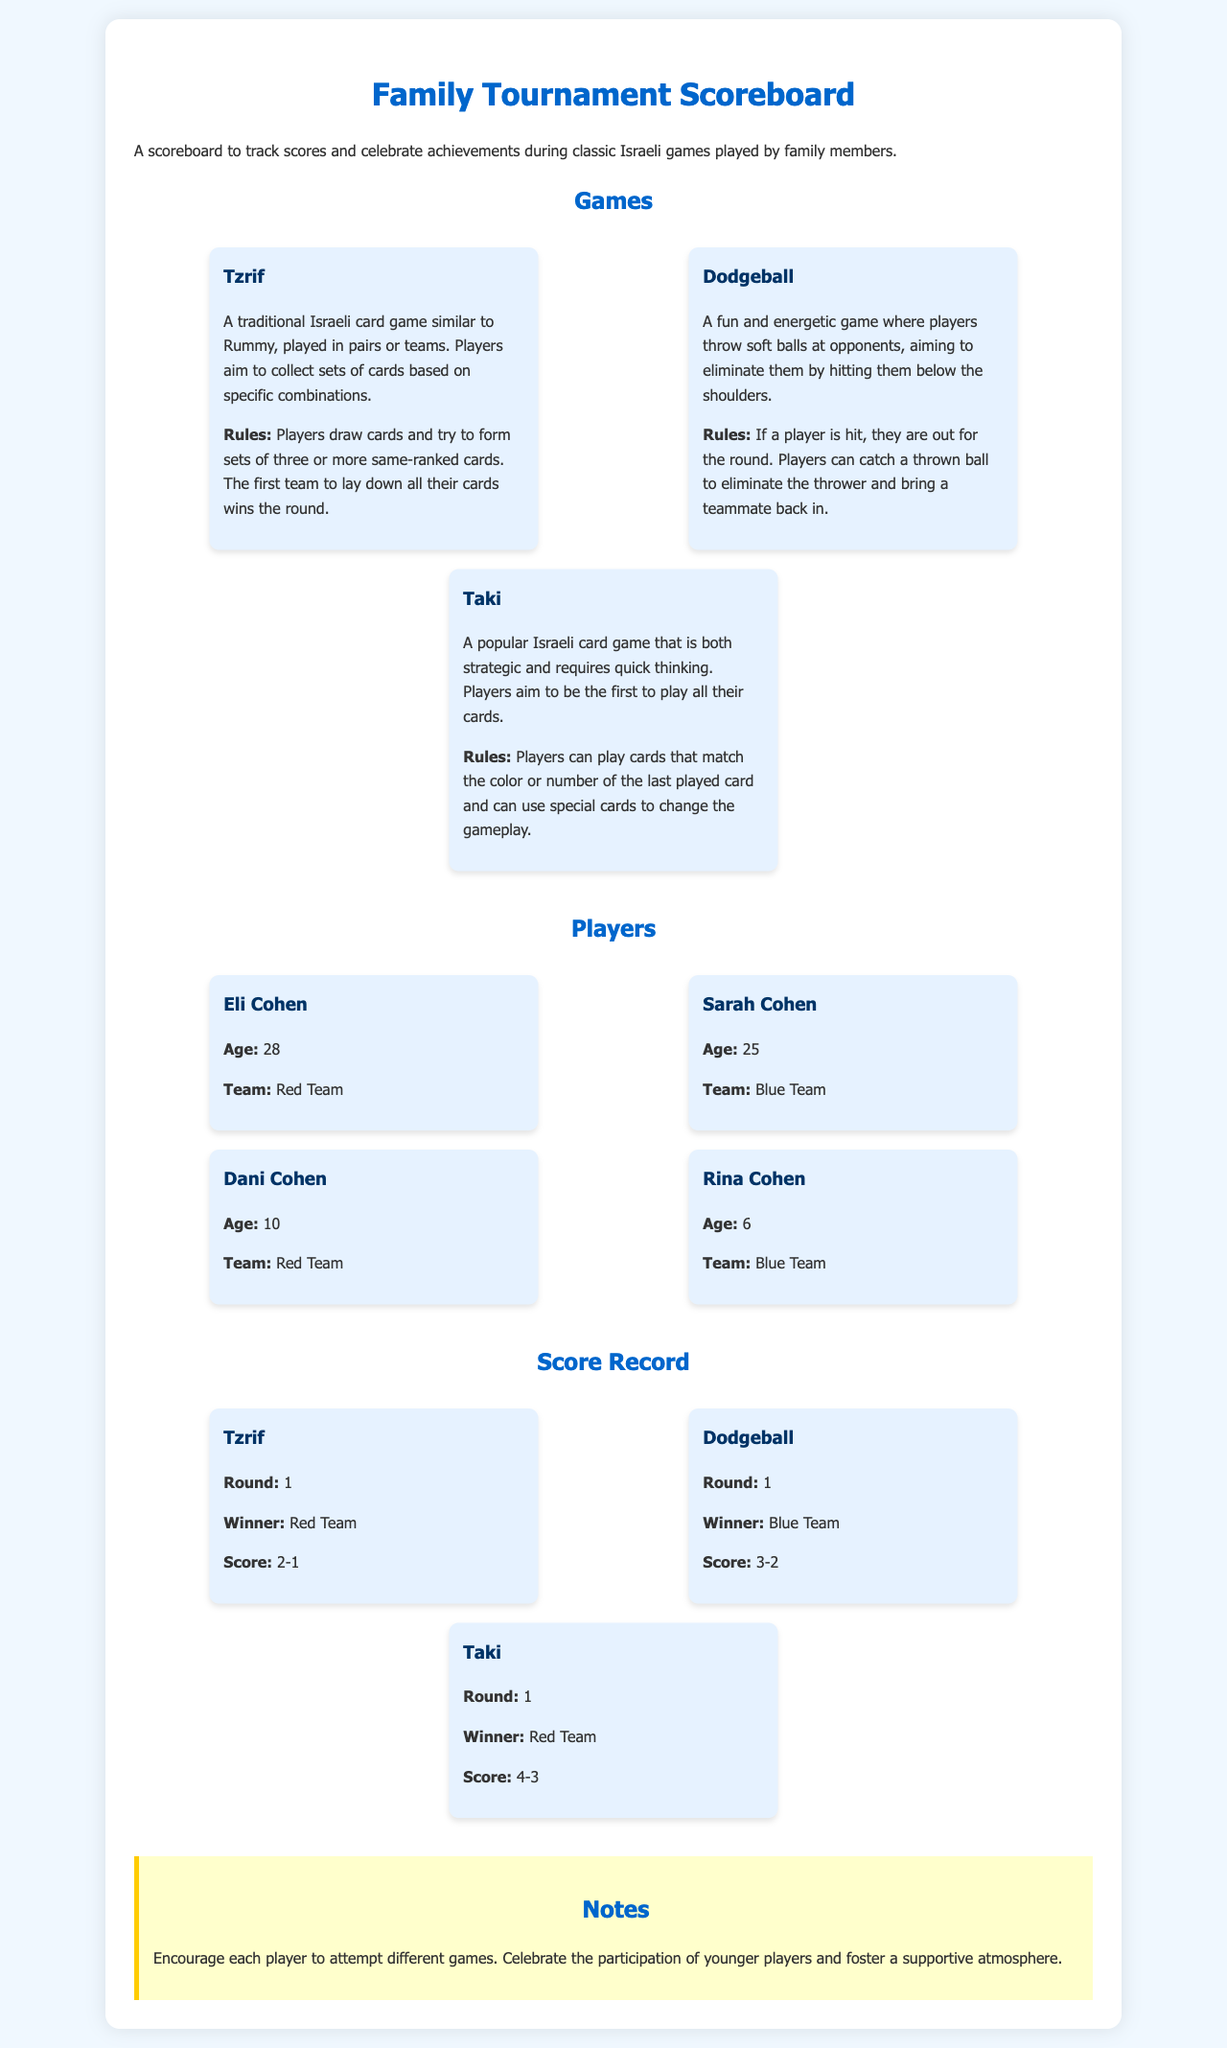What is the age of Eli Cohen? Eli Cohen's age is provided in the player list section of the document.
Answer: 28 What team does Sarah Cohen belong to? The document specifies the team affiliation of each player, including Sarah Cohen.
Answer: Blue Team Who won the first round of Tzrif? The scoreboard indicates the winners of each game, including Tzrif.
Answer: Red Team How many players are on the Red Team? The document lists all players along with their team designations, which can be used to count.
Answer: 2 What is the score in the first round of Dodgeball? The score for each game round is specified in the score record section of the document.
Answer: 3-2 What type of game is Taki described as? The description of Taki in the games section provides insights into its gameplay attributes and style.
Answer: Strategic Which game had the highest score in its first round? By comparing the scores from the score record section, one can determine which game had the highest score.
Answer: Taki What is one of the notes mentioned about players? The notes section includes advice and encouragement for players participating in the games.
Answer: Supportive atmosphere 